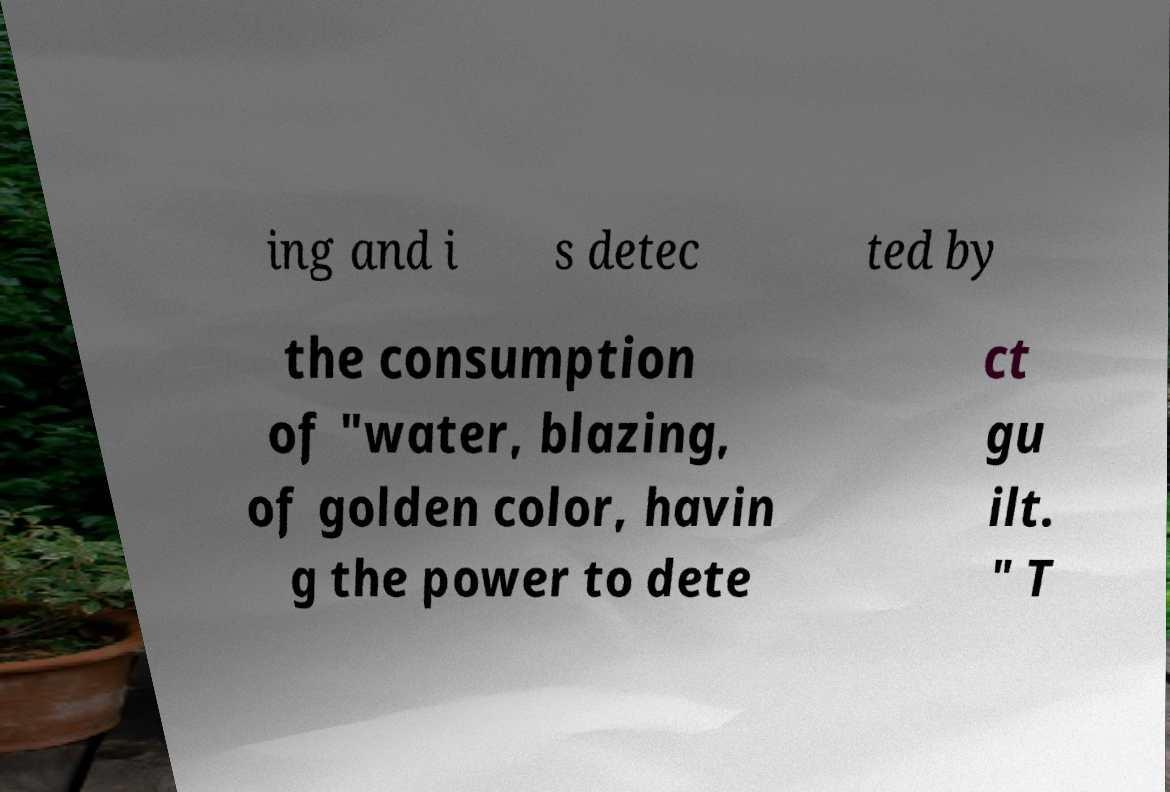Could you assist in decoding the text presented in this image and type it out clearly? ing and i s detec ted by the consumption of "water, blazing, of golden color, havin g the power to dete ct gu ilt. " T 